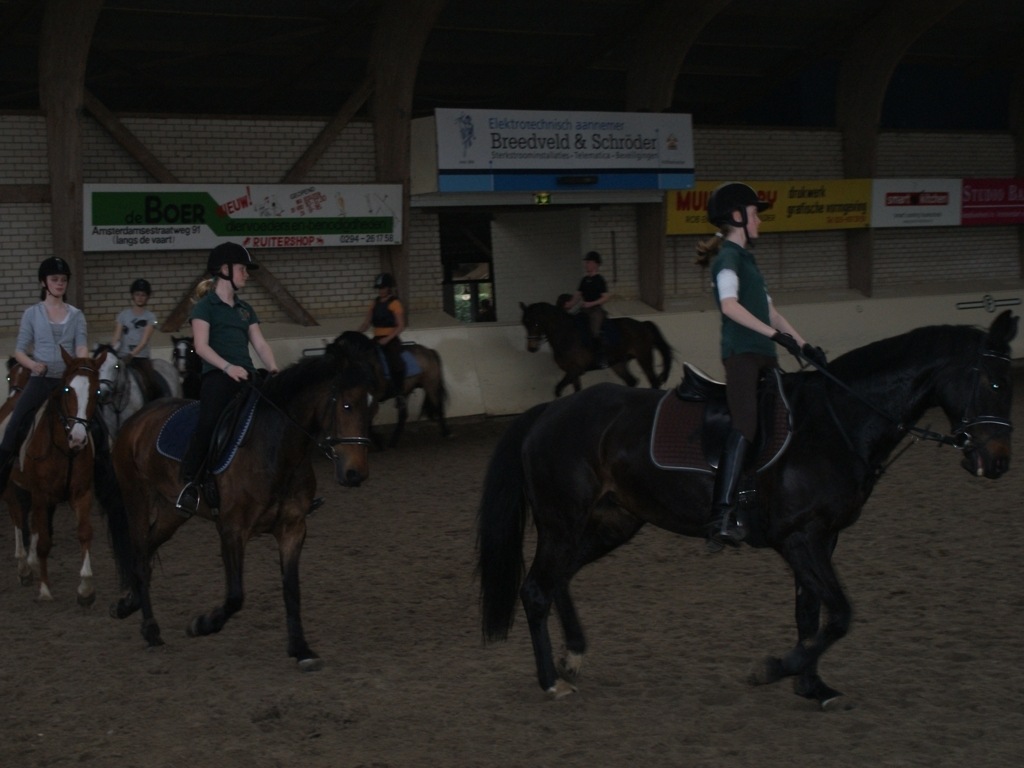What is the condition of the background? The background is somewhat unsharp, reducing the clarity of details, which can create a sense of depth and focus on the riders and horses in the foreground. 